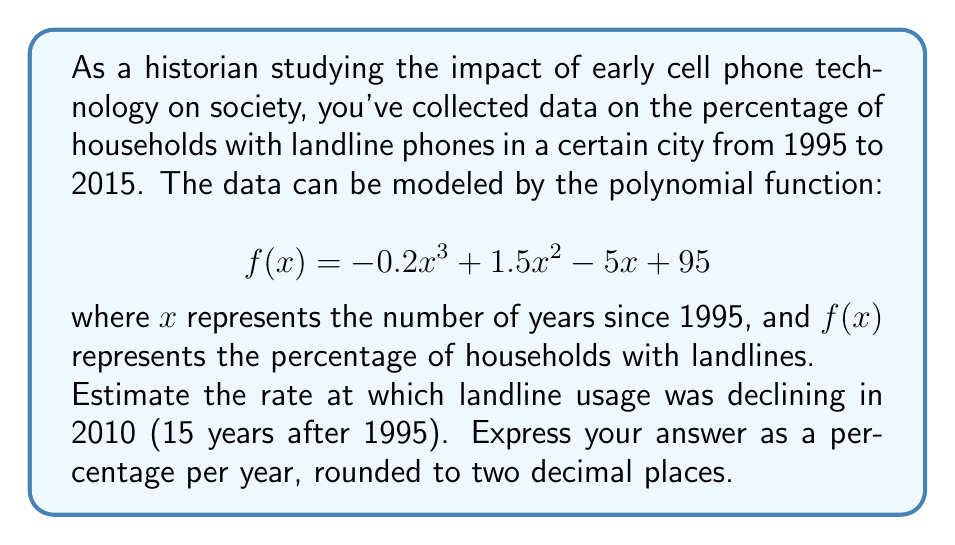What is the answer to this math problem? To solve this problem, we need to find the instantaneous rate of change of the function $f(x)$ at $x = 15$ (corresponding to the year 2010). This is equivalent to finding the derivative of $f(x)$ at $x = 15$.

Step 1: Find the derivative of $f(x)$.
$$f(x) = -0.2x^3 + 1.5x^2 - 5x + 95$$
$$f'(x) = -0.6x^2 + 3x - 5$$

Step 2: Evaluate $f'(15)$.
$$f'(15) = -0.6(15)^2 + 3(15) - 5$$
$$= -0.6(225) + 45 - 5$$
$$= -135 + 45 - 5$$
$$= -95$$

Step 3: Interpret the result.
The negative value indicates that the function is decreasing. The rate of change is -95 percentage points per year.

Step 4: Convert to a percentage.
Since we're already working with percentages, -95 percentage points per year is equivalent to a 95% decline per year.

Step 5: Round to two decimal places.
95.00%
Answer: 95.00% per year 